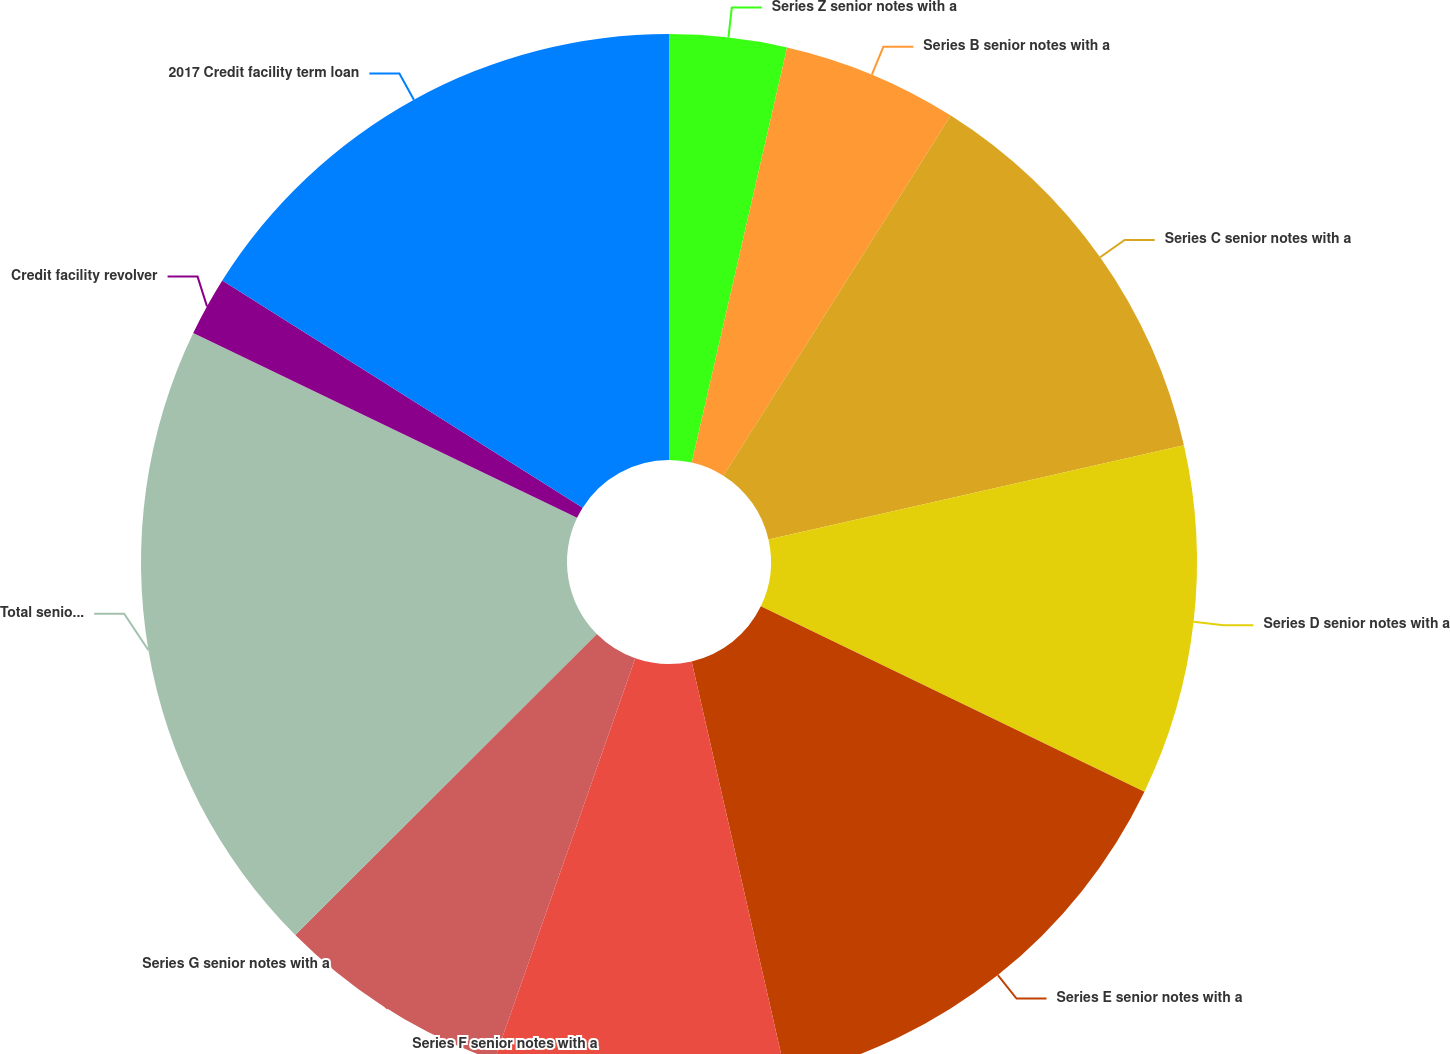<chart> <loc_0><loc_0><loc_500><loc_500><pie_chart><fcel>Series Z senior notes with a<fcel>Series B senior notes with a<fcel>Series C senior notes with a<fcel>Series D senior notes with a<fcel>Series E senior notes with a<fcel>Series F senior notes with a<fcel>Series G senior notes with a<fcel>Total senior notes<fcel>Credit facility revolver<fcel>2017 Credit facility term loan<nl><fcel>3.59%<fcel>5.37%<fcel>12.49%<fcel>10.71%<fcel>14.27%<fcel>8.93%<fcel>7.15%<fcel>19.62%<fcel>1.81%<fcel>16.05%<nl></chart> 